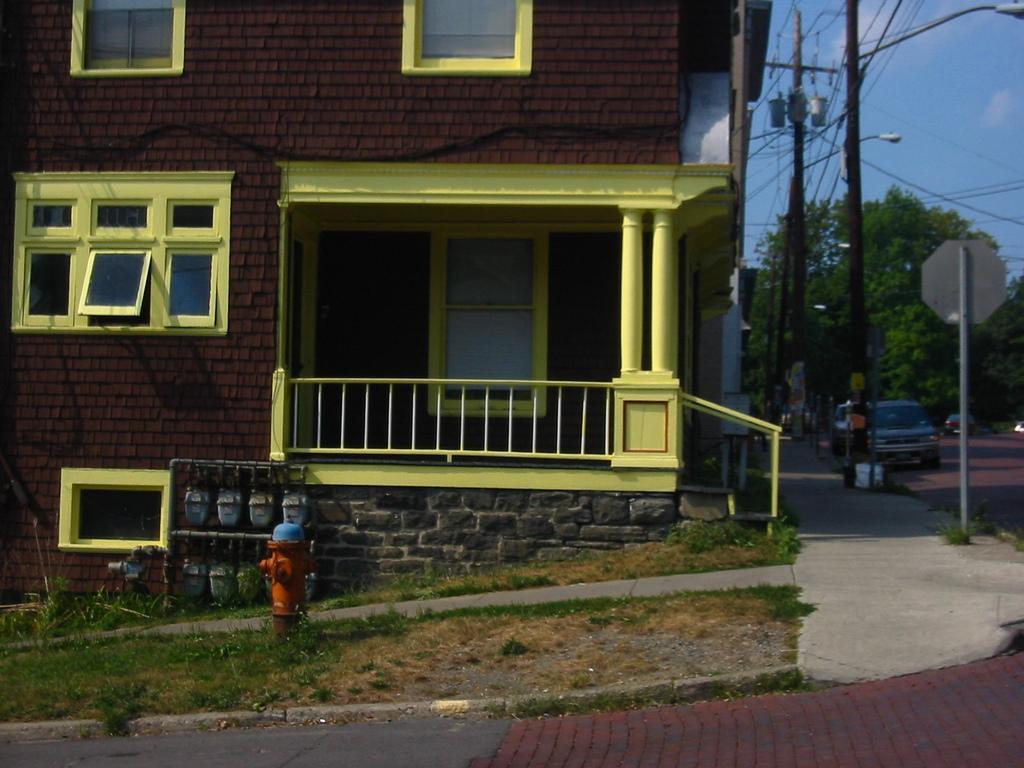Describe this image in one or two sentences. At the bottom of the image there is ground with grass and also there is a standpipe. Behind that there is a pole with few objects and hanging on it. In the image there is a building with brick walls, windows, poles and railing. In front of the building there is a footpath with sign board on a pole. And also there are few electrical poles with wires and street lights. On the right corner of the image there is a road with car. In the background there are trees. In the top right of the image there is sky. 